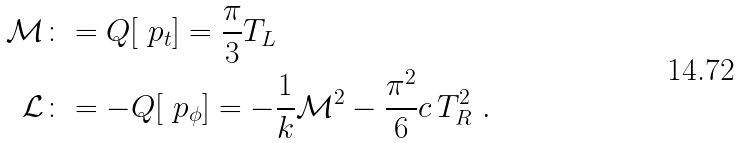<formula> <loc_0><loc_0><loc_500><loc_500>\mathcal { M } & \colon = Q [ \ p _ { t } ] = \frac { \pi } { 3 } T _ { L } \\ \mathcal { L } & \colon = - Q [ \ p _ { \phi } ] = - \frac { 1 } { k } \mathcal { M } ^ { 2 } - \frac { \pi ^ { 2 } } { 6 } c \, T _ { R } ^ { 2 } \ .</formula> 